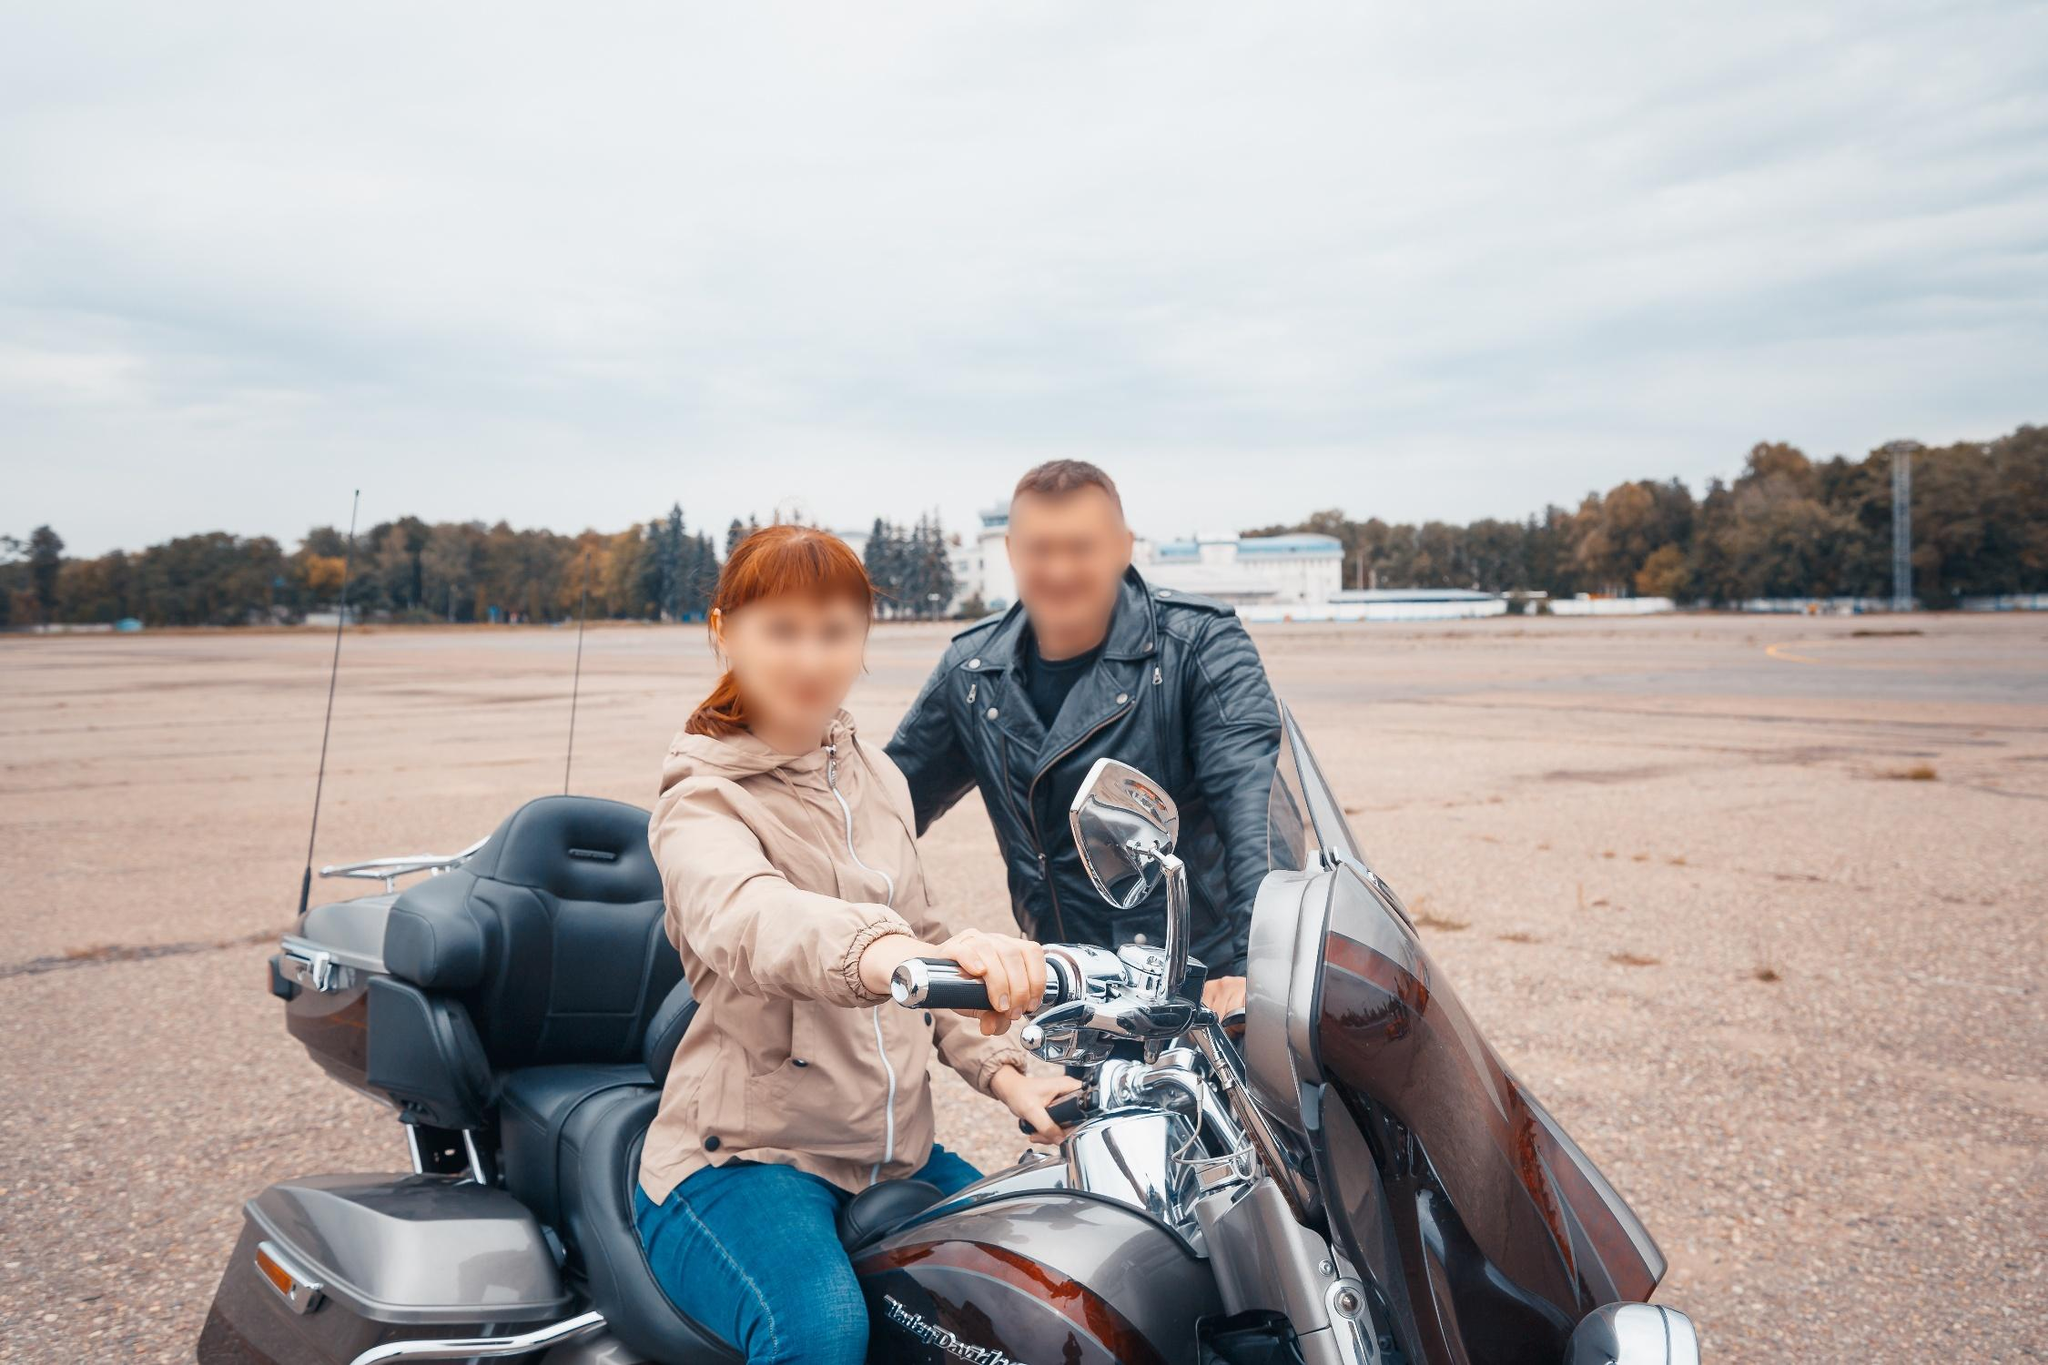Imagine an adventurous journey this couple might embark on with the motorcycle. The couple, equipped with their powerful Harley Davidson, might start their adventure from this tranquil, deserted lot. As they ride out, the engine roars to life, echoing through the empty space. They head towards winding country roads flanked by rolling hills and lush green forests, eventually reaching a scenic overlook. Here, they pause to admire a breathtaking sunset casting golden hues over a sprawling valley below. Their journey continues through quaint towns, stopping at roadside diners and historic landmarks, turning every mile into an unforgettable memory. The wind in their hair and the freedom of the open road defines their exhilarating experience. 